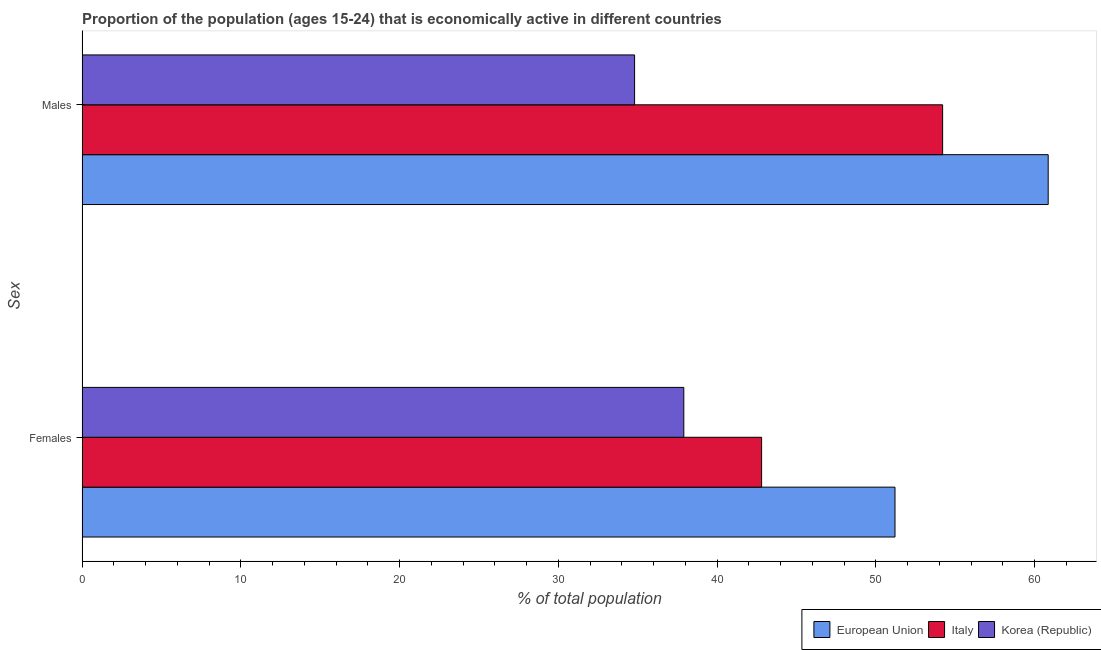How many groups of bars are there?
Ensure brevity in your answer.  2. How many bars are there on the 1st tick from the bottom?
Give a very brief answer. 3. What is the label of the 2nd group of bars from the top?
Offer a terse response. Females. What is the percentage of economically active female population in Italy?
Your answer should be compact. 42.8. Across all countries, what is the maximum percentage of economically active female population?
Ensure brevity in your answer.  51.2. Across all countries, what is the minimum percentage of economically active female population?
Offer a terse response. 37.9. What is the total percentage of economically active female population in the graph?
Your answer should be compact. 131.9. What is the difference between the percentage of economically active male population in Korea (Republic) and that in European Union?
Offer a very short reply. -26.05. What is the difference between the percentage of economically active male population in European Union and the percentage of economically active female population in Italy?
Make the answer very short. 18.05. What is the average percentage of economically active female population per country?
Provide a short and direct response. 43.97. What is the difference between the percentage of economically active male population and percentage of economically active female population in Italy?
Give a very brief answer. 11.4. In how many countries, is the percentage of economically active male population greater than 54 %?
Keep it short and to the point. 2. What is the ratio of the percentage of economically active female population in European Union to that in Italy?
Keep it short and to the point. 1.2. In how many countries, is the percentage of economically active female population greater than the average percentage of economically active female population taken over all countries?
Make the answer very short. 1. How many bars are there?
Offer a very short reply. 6. How many countries are there in the graph?
Your response must be concise. 3. What is the difference between two consecutive major ticks on the X-axis?
Offer a terse response. 10. Where does the legend appear in the graph?
Your answer should be compact. Bottom right. How many legend labels are there?
Keep it short and to the point. 3. How are the legend labels stacked?
Make the answer very short. Horizontal. What is the title of the graph?
Offer a very short reply. Proportion of the population (ages 15-24) that is economically active in different countries. What is the label or title of the X-axis?
Your response must be concise. % of total population. What is the label or title of the Y-axis?
Offer a very short reply. Sex. What is the % of total population in European Union in Females?
Keep it short and to the point. 51.2. What is the % of total population of Italy in Females?
Your answer should be compact. 42.8. What is the % of total population of Korea (Republic) in Females?
Give a very brief answer. 37.9. What is the % of total population in European Union in Males?
Ensure brevity in your answer.  60.85. What is the % of total population of Italy in Males?
Offer a terse response. 54.2. What is the % of total population in Korea (Republic) in Males?
Offer a terse response. 34.8. Across all Sex, what is the maximum % of total population in European Union?
Offer a very short reply. 60.85. Across all Sex, what is the maximum % of total population of Italy?
Your response must be concise. 54.2. Across all Sex, what is the maximum % of total population in Korea (Republic)?
Your answer should be very brief. 37.9. Across all Sex, what is the minimum % of total population in European Union?
Your response must be concise. 51.2. Across all Sex, what is the minimum % of total population in Italy?
Ensure brevity in your answer.  42.8. Across all Sex, what is the minimum % of total population of Korea (Republic)?
Your answer should be compact. 34.8. What is the total % of total population of European Union in the graph?
Offer a terse response. 112.05. What is the total % of total population in Italy in the graph?
Your answer should be compact. 97. What is the total % of total population in Korea (Republic) in the graph?
Provide a short and direct response. 72.7. What is the difference between the % of total population in European Union in Females and that in Males?
Provide a short and direct response. -9.65. What is the difference between the % of total population of European Union in Females and the % of total population of Italy in Males?
Make the answer very short. -3. What is the difference between the % of total population of European Union in Females and the % of total population of Korea (Republic) in Males?
Provide a succinct answer. 16.4. What is the difference between the % of total population in Italy in Females and the % of total population in Korea (Republic) in Males?
Provide a short and direct response. 8. What is the average % of total population in European Union per Sex?
Provide a succinct answer. 56.02. What is the average % of total population of Italy per Sex?
Keep it short and to the point. 48.5. What is the average % of total population in Korea (Republic) per Sex?
Give a very brief answer. 36.35. What is the difference between the % of total population of European Union and % of total population of Italy in Females?
Provide a short and direct response. 8.4. What is the difference between the % of total population of European Union and % of total population of Korea (Republic) in Females?
Your answer should be very brief. 13.3. What is the difference between the % of total population of European Union and % of total population of Italy in Males?
Ensure brevity in your answer.  6.65. What is the difference between the % of total population in European Union and % of total population in Korea (Republic) in Males?
Give a very brief answer. 26.05. What is the difference between the % of total population of Italy and % of total population of Korea (Republic) in Males?
Offer a very short reply. 19.4. What is the ratio of the % of total population in European Union in Females to that in Males?
Keep it short and to the point. 0.84. What is the ratio of the % of total population in Italy in Females to that in Males?
Offer a terse response. 0.79. What is the ratio of the % of total population in Korea (Republic) in Females to that in Males?
Your answer should be very brief. 1.09. What is the difference between the highest and the second highest % of total population of European Union?
Your answer should be compact. 9.65. What is the difference between the highest and the second highest % of total population in Italy?
Your answer should be compact. 11.4. What is the difference between the highest and the lowest % of total population of European Union?
Provide a short and direct response. 9.65. What is the difference between the highest and the lowest % of total population in Korea (Republic)?
Your response must be concise. 3.1. 